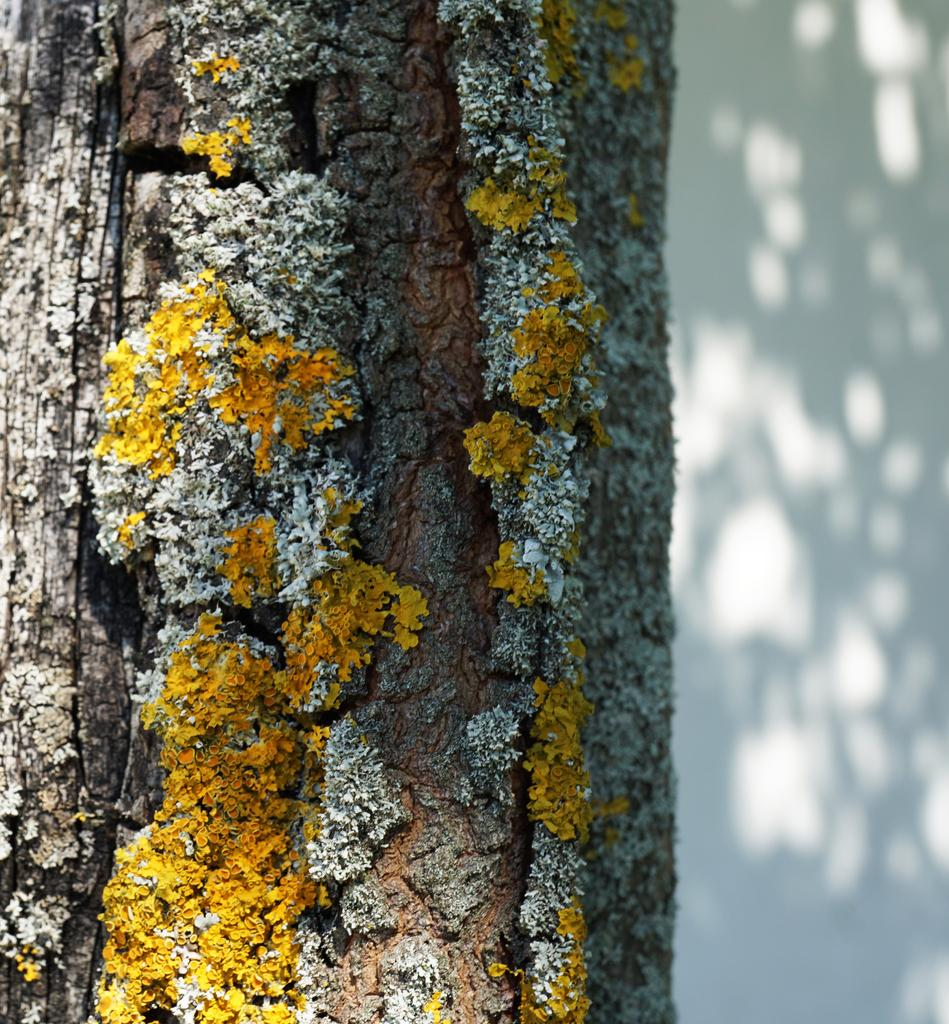What is located in the left corner of the image? There is a tree trunk in the left corner of the image. What can be seen on the tree trunk? There is a yellow color item on the tree trunk. What is in the right corner of the image? There is a wall in the right corner of the image. What type of cracker is being used to solve the riddle on the tree trunk? There is no cracker or riddle present in the image. What color are the trousers of the person standing next to the wall? There is no person or trousers mentioned in the provided facts, so we cannot answer this question. 